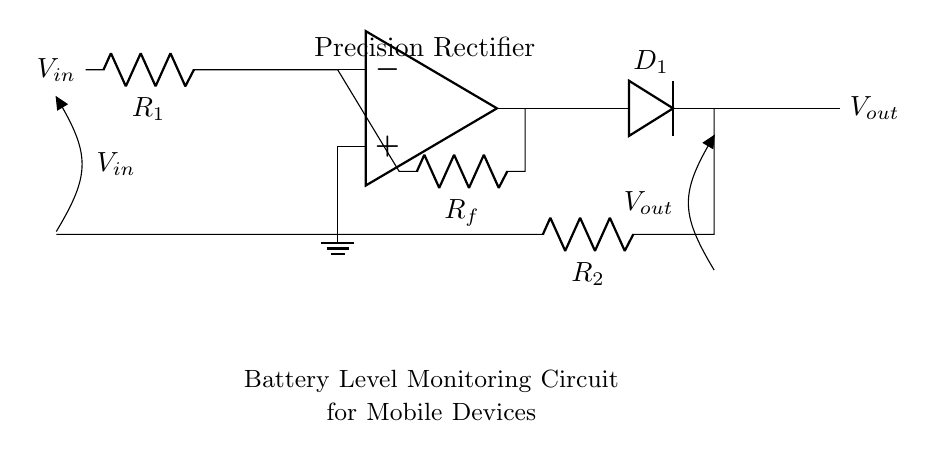What is the function of the op-amp in this circuit? The op-amp functions as a comparator and amplifier, enabling precise rectification by controlling the output voltage in response to the input signal.
Answer: Comparator and amplifier What is the role of the diode in the circuit? The diode allows current to flow in one direction, enabling the rectification process while blocking reverse current, which helps in obtaining a positive output voltage from an AC input.
Answer: Rectification How many resistors are present in the circuit? There are three resistors labeled R1, R2, and Rf, which are used for various purposes such as feedback and input resistance.
Answer: Three What is the output voltage of the circuit when the input voltage is zero? The output voltage remains zero when the input voltage is zero, as there is no input signal to generate an output.
Answer: Zero What type of rectifier is this circuit? This circuit is classified as a precision rectifier, which is designed to provide accurate output voltages, even for low-level input signals.
Answer: Precision rectifier What does the label "Battery Level Monitoring Circuit" indicate about the circuit's purpose? It suggests that the circuit is intended for monitoring the voltage levels of batteries in mobile devices, ensuring accurate readings for user displays or system functions.
Answer: Voltage monitoring 